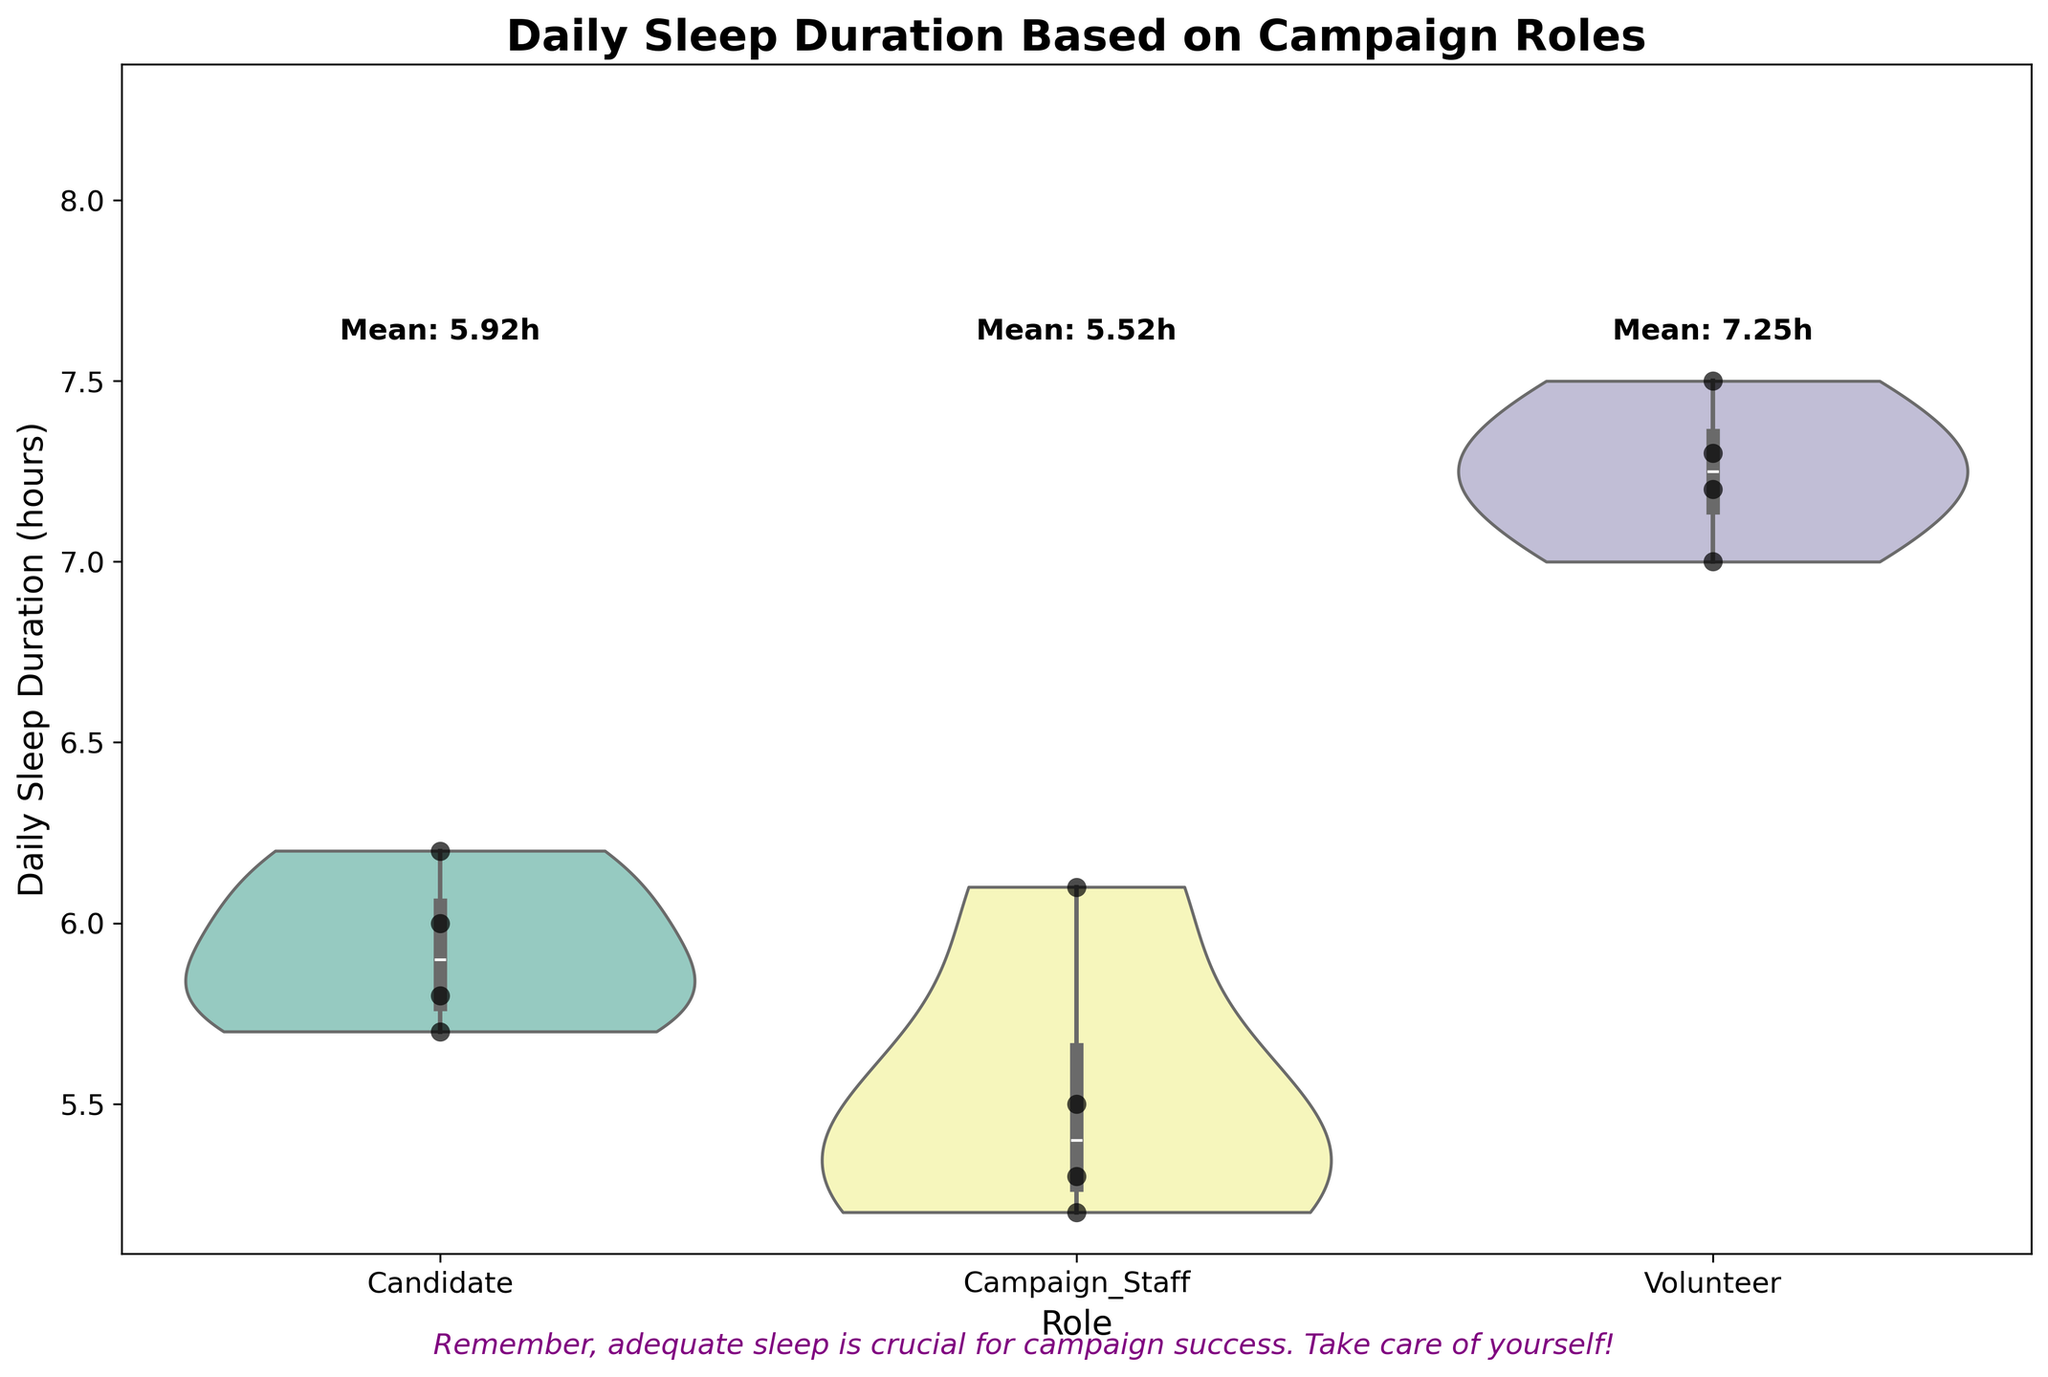Which campaign role has the highest mean daily sleep duration? The mean daily sleep duration is shown above each group in the plot. Look for the group with the highest mean value.
Answer: Volunteers What is the daily sleep range for campaign staff as demonstrated by the plot? Violin plots show the distribution of data points. Identify the uppermost and lowermost points of the violin plot for campaign staff.
Answer: 5.2 to 6.1 hours How many individual data points are shown for candidates? Look at each black dot within the Candidates section. Count the dots to find the number of data points.
Answer: 4 Compare the average sleep duration of candidates with that of campaign staff. Which group sleeps more on average? The figure provides mean sleep durations for each group. Compare the mean values presented for candidates and campaign staff.
Answer: Candidates Which group has the widest variability in daily sleep duration, according to the plot's spread? The width and spread of the violin plot represent variability. The group with the broadest and most spread out shape has the highest variability.
Answer: Volunteers What is the title of the plot? The title is displayed at the top of the figure. It describes the content of the plot.
Answer: Daily Sleep Duration Based on Campaign Roles What insight does the supportive message at the bottom of the plot give? The message is directly written at the bottom. Read it to understand the supportive advice provided.
Answer: Adequate sleep is crucial for campaign success How does the sleep duration of Elizabeth Wilson compare to the rest of the campaign staff? Identify Elizabeth Wilson’s data point among campaign staff and compare its value (5.2 hours) to other individual data points.
Answer: She has one of the lowest sleep durations in her group What specific data visual element highlights individual data points? Look for visual markers that denote individual values within each violin plot area.
Answer: Black dots (swarm plot) 